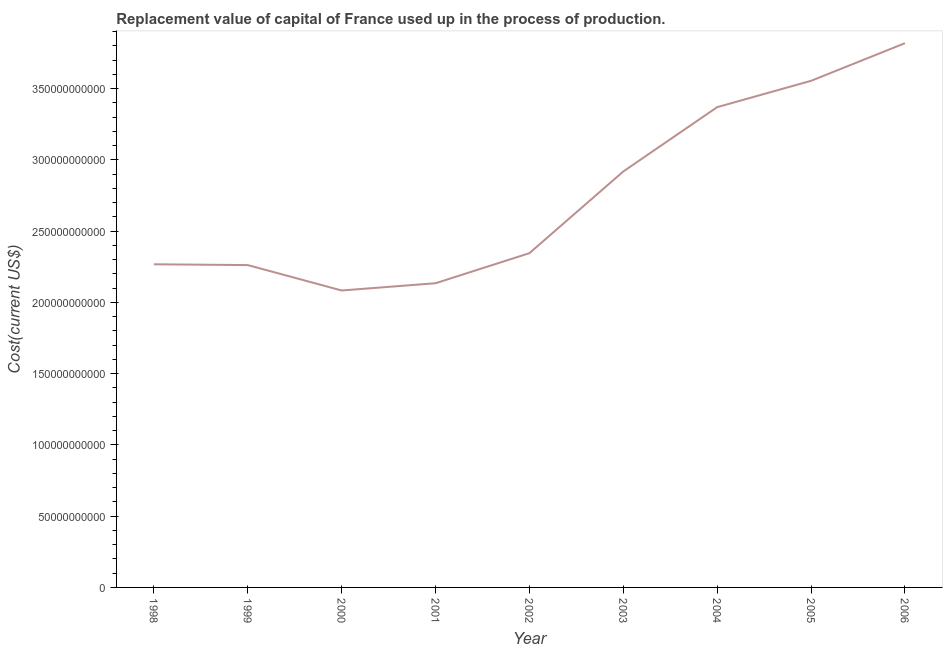What is the consumption of fixed capital in 2006?
Give a very brief answer. 3.82e+11. Across all years, what is the maximum consumption of fixed capital?
Provide a short and direct response. 3.82e+11. Across all years, what is the minimum consumption of fixed capital?
Provide a short and direct response. 2.08e+11. In which year was the consumption of fixed capital minimum?
Offer a very short reply. 2000. What is the sum of the consumption of fixed capital?
Your answer should be compact. 2.48e+12. What is the difference between the consumption of fixed capital in 2000 and 2006?
Your answer should be compact. -1.74e+11. What is the average consumption of fixed capital per year?
Your response must be concise. 2.75e+11. What is the median consumption of fixed capital?
Offer a very short reply. 2.35e+11. In how many years, is the consumption of fixed capital greater than 310000000000 US$?
Your response must be concise. 3. What is the ratio of the consumption of fixed capital in 2001 to that in 2006?
Your answer should be very brief. 0.56. Is the consumption of fixed capital in 1998 less than that in 1999?
Make the answer very short. No. What is the difference between the highest and the second highest consumption of fixed capital?
Ensure brevity in your answer.  2.64e+1. What is the difference between the highest and the lowest consumption of fixed capital?
Provide a succinct answer. 1.74e+11. Does the consumption of fixed capital monotonically increase over the years?
Ensure brevity in your answer.  No. How many lines are there?
Your response must be concise. 1. Are the values on the major ticks of Y-axis written in scientific E-notation?
Your response must be concise. No. What is the title of the graph?
Give a very brief answer. Replacement value of capital of France used up in the process of production. What is the label or title of the Y-axis?
Your answer should be compact. Cost(current US$). What is the Cost(current US$) in 1998?
Give a very brief answer. 2.27e+11. What is the Cost(current US$) of 1999?
Give a very brief answer. 2.26e+11. What is the Cost(current US$) in 2000?
Keep it short and to the point. 2.08e+11. What is the Cost(current US$) in 2001?
Your response must be concise. 2.13e+11. What is the Cost(current US$) in 2002?
Provide a short and direct response. 2.35e+11. What is the Cost(current US$) of 2003?
Provide a succinct answer. 2.92e+11. What is the Cost(current US$) in 2004?
Provide a short and direct response. 3.37e+11. What is the Cost(current US$) of 2005?
Make the answer very short. 3.56e+11. What is the Cost(current US$) of 2006?
Give a very brief answer. 3.82e+11. What is the difference between the Cost(current US$) in 1998 and 1999?
Keep it short and to the point. 5.69e+08. What is the difference between the Cost(current US$) in 1998 and 2000?
Ensure brevity in your answer.  1.84e+1. What is the difference between the Cost(current US$) in 1998 and 2001?
Make the answer very short. 1.33e+1. What is the difference between the Cost(current US$) in 1998 and 2002?
Ensure brevity in your answer.  -7.79e+09. What is the difference between the Cost(current US$) in 1998 and 2003?
Ensure brevity in your answer.  -6.51e+1. What is the difference between the Cost(current US$) in 1998 and 2004?
Make the answer very short. -1.10e+11. What is the difference between the Cost(current US$) in 1998 and 2005?
Provide a succinct answer. -1.29e+11. What is the difference between the Cost(current US$) in 1998 and 2006?
Give a very brief answer. -1.55e+11. What is the difference between the Cost(current US$) in 1999 and 2000?
Give a very brief answer. 1.78e+1. What is the difference between the Cost(current US$) in 1999 and 2001?
Your answer should be very brief. 1.27e+1. What is the difference between the Cost(current US$) in 1999 and 2002?
Offer a terse response. -8.36e+09. What is the difference between the Cost(current US$) in 1999 and 2003?
Your answer should be very brief. -6.57e+1. What is the difference between the Cost(current US$) in 1999 and 2004?
Keep it short and to the point. -1.11e+11. What is the difference between the Cost(current US$) in 1999 and 2005?
Ensure brevity in your answer.  -1.29e+11. What is the difference between the Cost(current US$) in 1999 and 2006?
Offer a very short reply. -1.56e+11. What is the difference between the Cost(current US$) in 2000 and 2001?
Keep it short and to the point. -5.09e+09. What is the difference between the Cost(current US$) in 2000 and 2002?
Make the answer very short. -2.62e+1. What is the difference between the Cost(current US$) in 2000 and 2003?
Provide a short and direct response. -8.35e+1. What is the difference between the Cost(current US$) in 2000 and 2004?
Give a very brief answer. -1.29e+11. What is the difference between the Cost(current US$) in 2000 and 2005?
Keep it short and to the point. -1.47e+11. What is the difference between the Cost(current US$) in 2000 and 2006?
Make the answer very short. -1.74e+11. What is the difference between the Cost(current US$) in 2001 and 2002?
Offer a very short reply. -2.11e+1. What is the difference between the Cost(current US$) in 2001 and 2003?
Offer a terse response. -7.84e+1. What is the difference between the Cost(current US$) in 2001 and 2004?
Offer a very short reply. -1.24e+11. What is the difference between the Cost(current US$) in 2001 and 2005?
Offer a very short reply. -1.42e+11. What is the difference between the Cost(current US$) in 2001 and 2006?
Your answer should be very brief. -1.68e+11. What is the difference between the Cost(current US$) in 2002 and 2003?
Keep it short and to the point. -5.73e+1. What is the difference between the Cost(current US$) in 2002 and 2004?
Give a very brief answer. -1.02e+11. What is the difference between the Cost(current US$) in 2002 and 2005?
Offer a terse response. -1.21e+11. What is the difference between the Cost(current US$) in 2002 and 2006?
Your answer should be very brief. -1.47e+11. What is the difference between the Cost(current US$) in 2003 and 2004?
Ensure brevity in your answer.  -4.51e+1. What is the difference between the Cost(current US$) in 2003 and 2005?
Your answer should be compact. -6.36e+1. What is the difference between the Cost(current US$) in 2003 and 2006?
Keep it short and to the point. -9.00e+1. What is the difference between the Cost(current US$) in 2004 and 2005?
Your response must be concise. -1.85e+1. What is the difference between the Cost(current US$) in 2004 and 2006?
Offer a terse response. -4.49e+1. What is the difference between the Cost(current US$) in 2005 and 2006?
Your answer should be compact. -2.64e+1. What is the ratio of the Cost(current US$) in 1998 to that in 1999?
Give a very brief answer. 1. What is the ratio of the Cost(current US$) in 1998 to that in 2000?
Ensure brevity in your answer.  1.09. What is the ratio of the Cost(current US$) in 1998 to that in 2001?
Your response must be concise. 1.06. What is the ratio of the Cost(current US$) in 1998 to that in 2002?
Keep it short and to the point. 0.97. What is the ratio of the Cost(current US$) in 1998 to that in 2003?
Offer a very short reply. 0.78. What is the ratio of the Cost(current US$) in 1998 to that in 2004?
Offer a terse response. 0.67. What is the ratio of the Cost(current US$) in 1998 to that in 2005?
Make the answer very short. 0.64. What is the ratio of the Cost(current US$) in 1998 to that in 2006?
Provide a short and direct response. 0.59. What is the ratio of the Cost(current US$) in 1999 to that in 2000?
Give a very brief answer. 1.09. What is the ratio of the Cost(current US$) in 1999 to that in 2001?
Provide a succinct answer. 1.06. What is the ratio of the Cost(current US$) in 1999 to that in 2002?
Keep it short and to the point. 0.96. What is the ratio of the Cost(current US$) in 1999 to that in 2003?
Provide a succinct answer. 0.78. What is the ratio of the Cost(current US$) in 1999 to that in 2004?
Ensure brevity in your answer.  0.67. What is the ratio of the Cost(current US$) in 1999 to that in 2005?
Your answer should be very brief. 0.64. What is the ratio of the Cost(current US$) in 1999 to that in 2006?
Provide a short and direct response. 0.59. What is the ratio of the Cost(current US$) in 2000 to that in 2001?
Your answer should be compact. 0.98. What is the ratio of the Cost(current US$) in 2000 to that in 2002?
Ensure brevity in your answer.  0.89. What is the ratio of the Cost(current US$) in 2000 to that in 2003?
Provide a succinct answer. 0.71. What is the ratio of the Cost(current US$) in 2000 to that in 2004?
Offer a very short reply. 0.62. What is the ratio of the Cost(current US$) in 2000 to that in 2005?
Give a very brief answer. 0.59. What is the ratio of the Cost(current US$) in 2000 to that in 2006?
Give a very brief answer. 0.55. What is the ratio of the Cost(current US$) in 2001 to that in 2002?
Ensure brevity in your answer.  0.91. What is the ratio of the Cost(current US$) in 2001 to that in 2003?
Your answer should be very brief. 0.73. What is the ratio of the Cost(current US$) in 2001 to that in 2004?
Keep it short and to the point. 0.63. What is the ratio of the Cost(current US$) in 2001 to that in 2005?
Your answer should be compact. 0.6. What is the ratio of the Cost(current US$) in 2001 to that in 2006?
Your response must be concise. 0.56. What is the ratio of the Cost(current US$) in 2002 to that in 2003?
Ensure brevity in your answer.  0.8. What is the ratio of the Cost(current US$) in 2002 to that in 2004?
Offer a terse response. 0.7. What is the ratio of the Cost(current US$) in 2002 to that in 2005?
Offer a terse response. 0.66. What is the ratio of the Cost(current US$) in 2002 to that in 2006?
Your answer should be very brief. 0.61. What is the ratio of the Cost(current US$) in 2003 to that in 2004?
Your answer should be very brief. 0.87. What is the ratio of the Cost(current US$) in 2003 to that in 2005?
Provide a short and direct response. 0.82. What is the ratio of the Cost(current US$) in 2003 to that in 2006?
Your answer should be very brief. 0.76. What is the ratio of the Cost(current US$) in 2004 to that in 2005?
Make the answer very short. 0.95. What is the ratio of the Cost(current US$) in 2004 to that in 2006?
Keep it short and to the point. 0.88. What is the ratio of the Cost(current US$) in 2005 to that in 2006?
Ensure brevity in your answer.  0.93. 